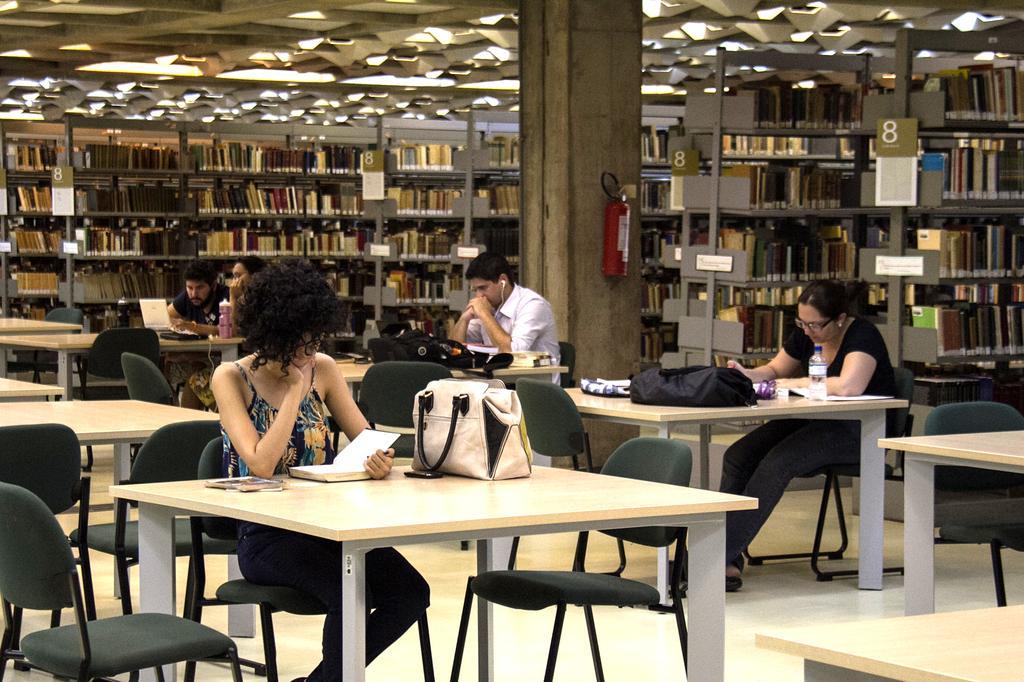Could you give a brief overview of what you see in this image? In this image we can see a library. There are a few people who are sitting on a chair and they are reading a book. 